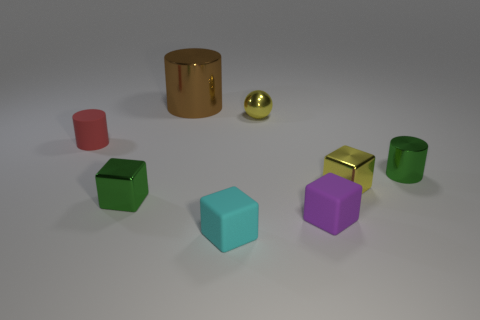Subtract 2 blocks. How many blocks are left? 2 Subtract all cyan cubes. How many cubes are left? 3 Subtract all small green cylinders. How many cylinders are left? 2 Subtract all brown cubes. Subtract all purple balls. How many cubes are left? 4 Add 2 green objects. How many objects exist? 10 Subtract all cylinders. How many objects are left? 5 Add 2 tiny red cubes. How many tiny red cubes exist? 2 Subtract 0 yellow cylinders. How many objects are left? 8 Subtract all large brown rubber cylinders. Subtract all large brown objects. How many objects are left? 7 Add 2 tiny metallic cubes. How many tiny metallic cubes are left? 4 